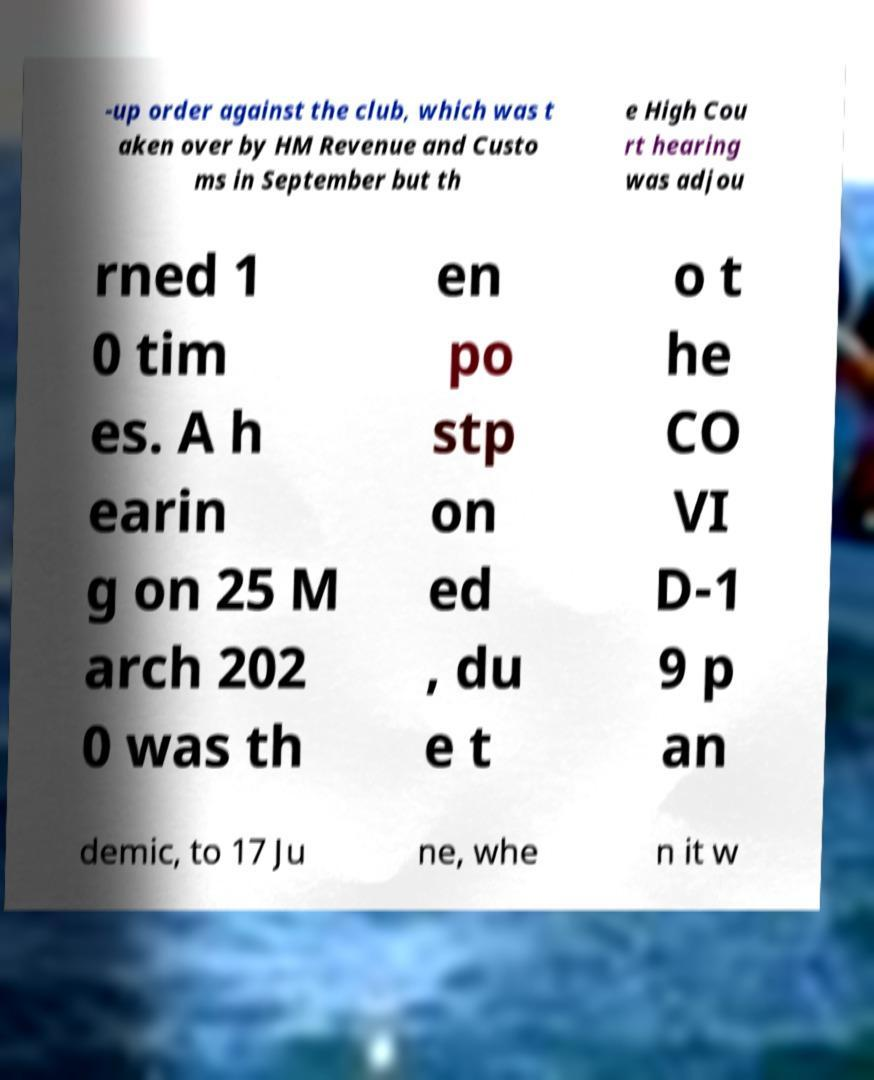What messages or text are displayed in this image? I need them in a readable, typed format. -up order against the club, which was t aken over by HM Revenue and Custo ms in September but th e High Cou rt hearing was adjou rned 1 0 tim es. A h earin g on 25 M arch 202 0 was th en po stp on ed , du e t o t he CO VI D-1 9 p an demic, to 17 Ju ne, whe n it w 